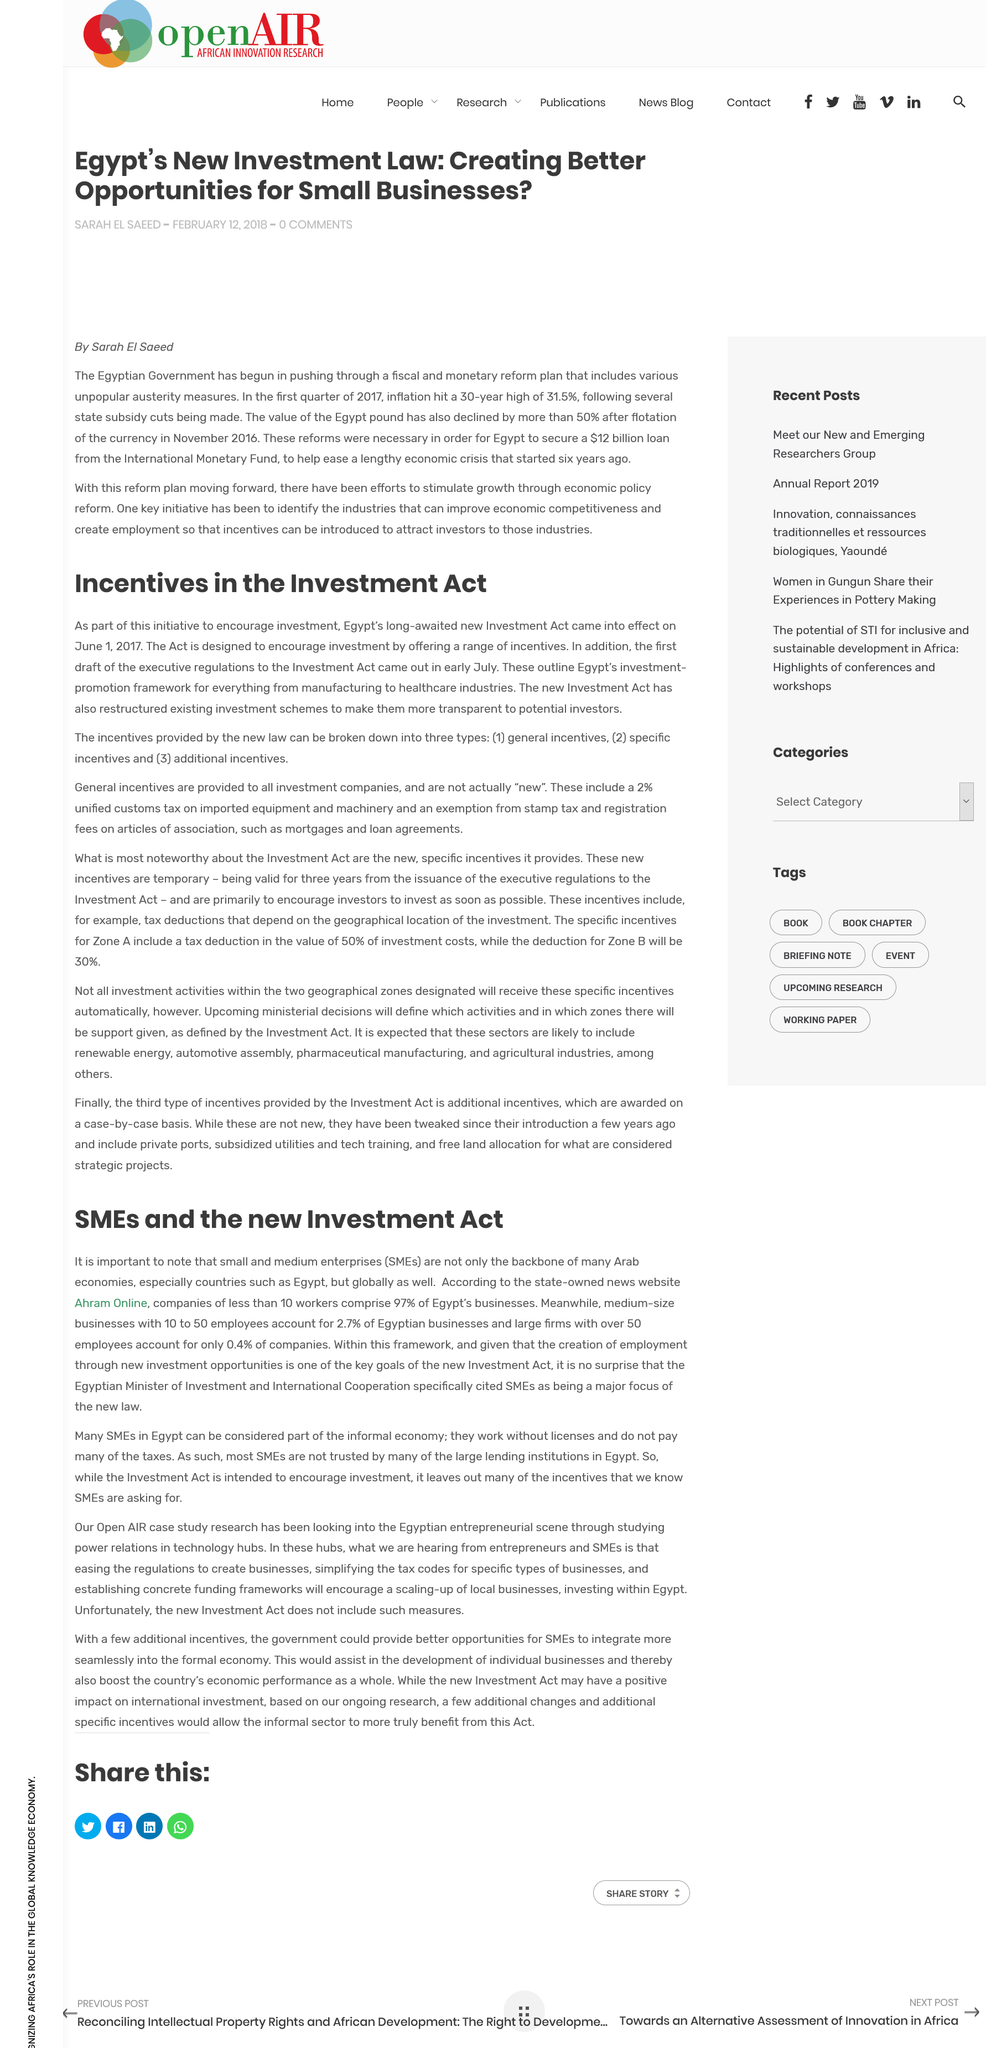Specify some key components in this picture. Egypt's Investment Act became effective on June 1, 2017. SMEs have now become a focal point of the new law, as declared by the Egyptian Minister of Investment and International Cooperation. Small and Medium Enterprises (SMEs) refer to small businesses and medium-sized businesses that play a significant role in the economy and are vital to the growth and development of a country. The state-owned news website Ahram Online reported that 97% of Egypt's businesses have fewer than 10 workers. The Investment Act is a legislative measure intended to stimulate investment by providing various enticements to potential investors. 